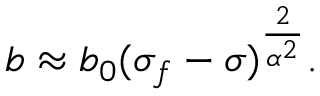<formula> <loc_0><loc_0><loc_500><loc_500>{ b \approx b _ { 0 } ( \sigma _ { f } - \sigma ) ^ { \frac { 2 } { \alpha ^ { 2 } } } . }</formula> 